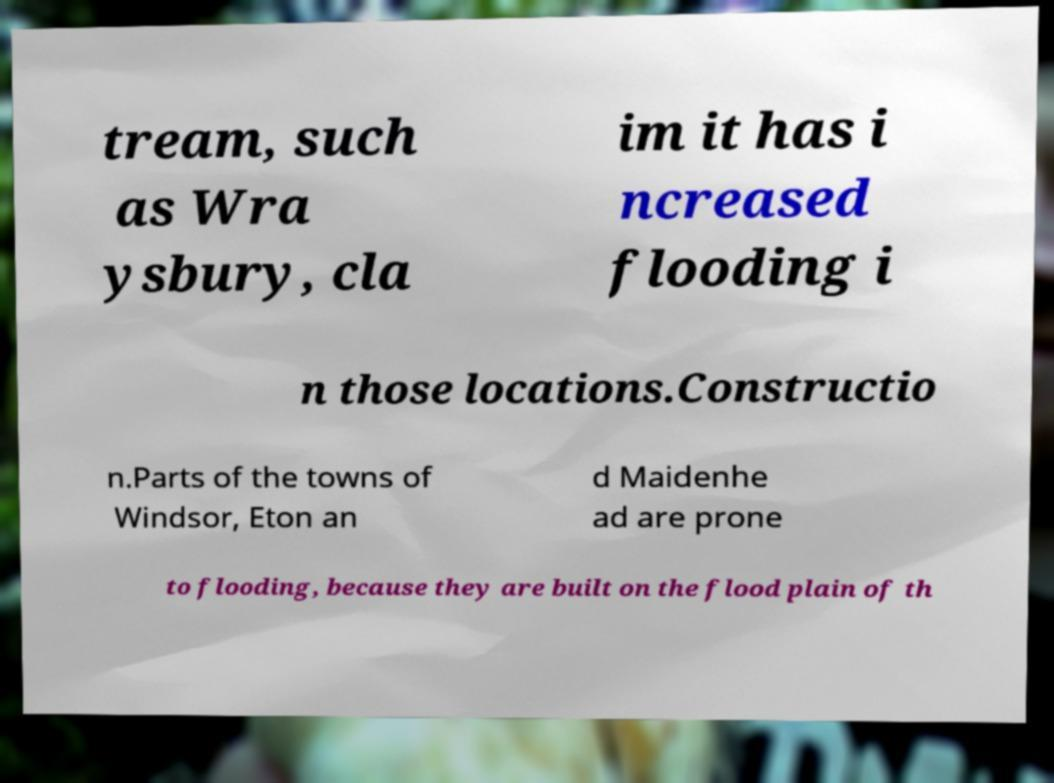What messages or text are displayed in this image? I need them in a readable, typed format. tream, such as Wra ysbury, cla im it has i ncreased flooding i n those locations.Constructio n.Parts of the towns of Windsor, Eton an d Maidenhe ad are prone to flooding, because they are built on the flood plain of th 